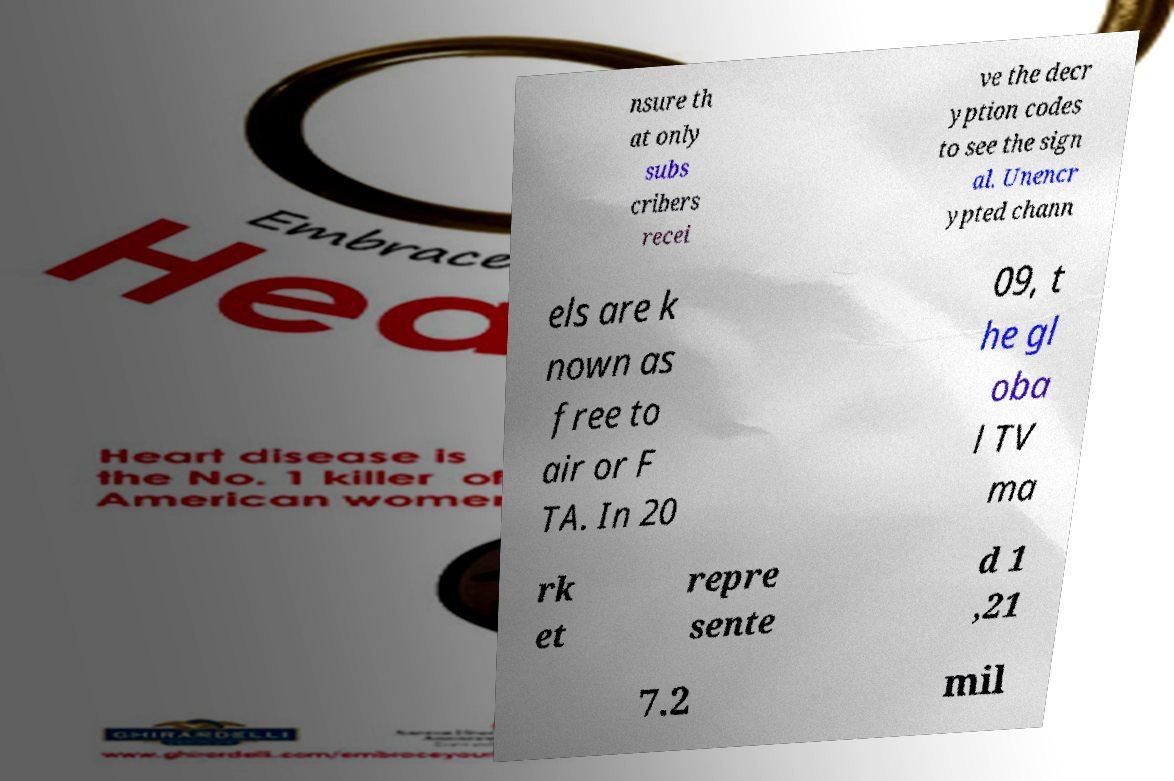Can you read and provide the text displayed in the image?This photo seems to have some interesting text. Can you extract and type it out for me? nsure th at only subs cribers recei ve the decr yption codes to see the sign al. Unencr ypted chann els are k nown as free to air or F TA. In 20 09, t he gl oba l TV ma rk et repre sente d 1 ,21 7.2 mil 